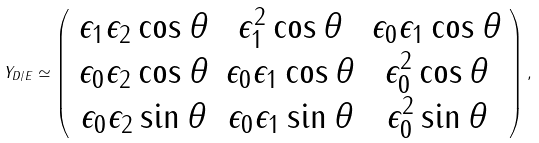Convert formula to latex. <formula><loc_0><loc_0><loc_500><loc_500>Y _ { D / E } \simeq \left ( \begin{array} { c c c } { { \epsilon _ { 1 } \epsilon _ { 2 } \cos \theta } } & { { \epsilon _ { 1 } ^ { 2 } \cos \theta } } & { { \epsilon _ { 0 } \epsilon _ { 1 } \cos \theta } } \\ { { \epsilon _ { 0 } \epsilon _ { 2 } \cos \theta } } & { { \epsilon _ { 0 } \epsilon _ { 1 } \cos \theta } } & { { \epsilon _ { 0 } ^ { 2 } \cos \theta } } \\ { { \epsilon _ { 0 } \epsilon _ { 2 } \sin \theta } } & { { \epsilon _ { 0 } \epsilon _ { 1 } \sin \theta } } & { { \epsilon _ { 0 } ^ { 2 } \sin \theta } } \end{array} \right ) ,</formula> 